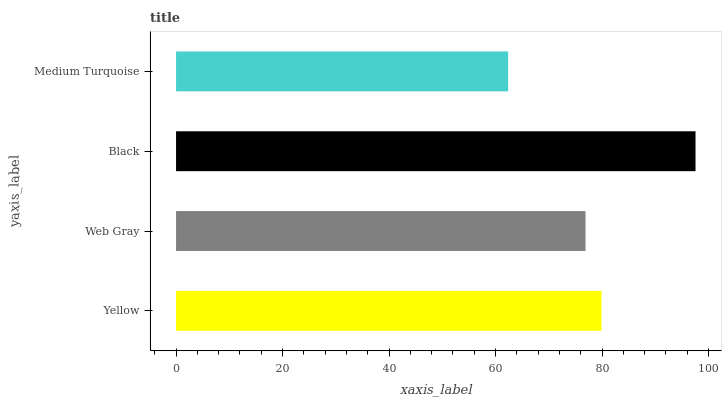Is Medium Turquoise the minimum?
Answer yes or no. Yes. Is Black the maximum?
Answer yes or no. Yes. Is Web Gray the minimum?
Answer yes or no. No. Is Web Gray the maximum?
Answer yes or no. No. Is Yellow greater than Web Gray?
Answer yes or no. Yes. Is Web Gray less than Yellow?
Answer yes or no. Yes. Is Web Gray greater than Yellow?
Answer yes or no. No. Is Yellow less than Web Gray?
Answer yes or no. No. Is Yellow the high median?
Answer yes or no. Yes. Is Web Gray the low median?
Answer yes or no. Yes. Is Web Gray the high median?
Answer yes or no. No. Is Black the low median?
Answer yes or no. No. 